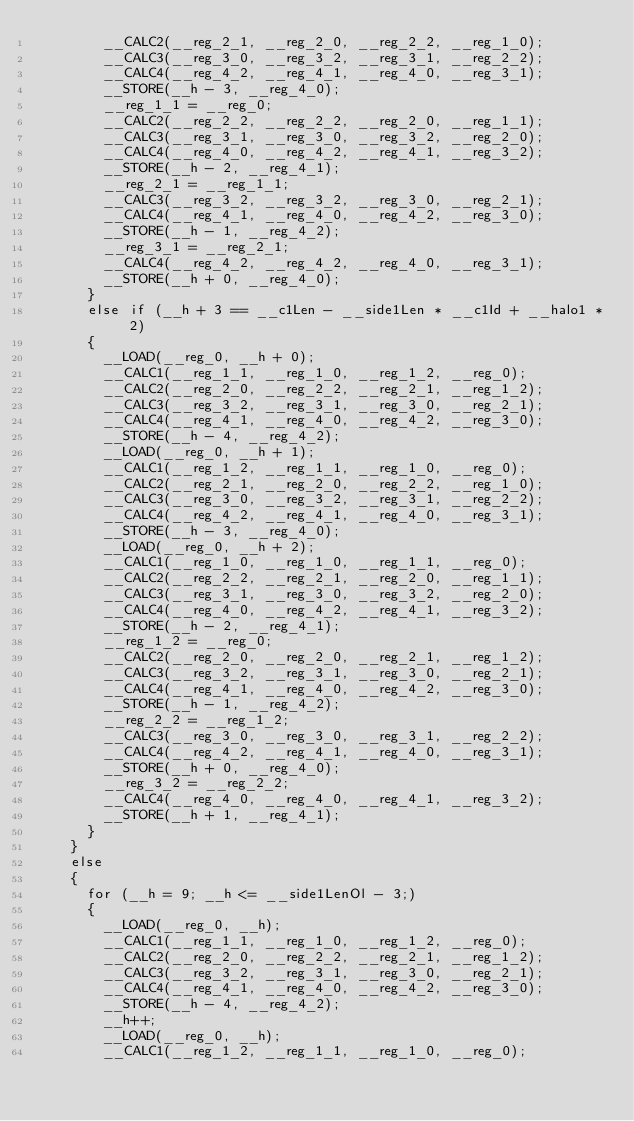<code> <loc_0><loc_0><loc_500><loc_500><_Cuda_>        __CALC2(__reg_2_1, __reg_2_0, __reg_2_2, __reg_1_0);
        __CALC3(__reg_3_0, __reg_3_2, __reg_3_1, __reg_2_2);
        __CALC4(__reg_4_2, __reg_4_1, __reg_4_0, __reg_3_1);
        __STORE(__h - 3, __reg_4_0);
        __reg_1_1 = __reg_0;
        __CALC2(__reg_2_2, __reg_2_2, __reg_2_0, __reg_1_1);
        __CALC3(__reg_3_1, __reg_3_0, __reg_3_2, __reg_2_0);
        __CALC4(__reg_4_0, __reg_4_2, __reg_4_1, __reg_3_2);
        __STORE(__h - 2, __reg_4_1);
        __reg_2_1 = __reg_1_1;
        __CALC3(__reg_3_2, __reg_3_2, __reg_3_0, __reg_2_1);
        __CALC4(__reg_4_1, __reg_4_0, __reg_4_2, __reg_3_0);
        __STORE(__h - 1, __reg_4_2);
        __reg_3_1 = __reg_2_1;
        __CALC4(__reg_4_2, __reg_4_2, __reg_4_0, __reg_3_1);
        __STORE(__h + 0, __reg_4_0);
      }
      else if (__h + 3 == __c1Len - __side1Len * __c1Id + __halo1 * 2)
      {
        __LOAD(__reg_0, __h + 0);
        __CALC1(__reg_1_1, __reg_1_0, __reg_1_2, __reg_0);
        __CALC2(__reg_2_0, __reg_2_2, __reg_2_1, __reg_1_2);
        __CALC3(__reg_3_2, __reg_3_1, __reg_3_0, __reg_2_1);
        __CALC4(__reg_4_1, __reg_4_0, __reg_4_2, __reg_3_0);
        __STORE(__h - 4, __reg_4_2);
        __LOAD(__reg_0, __h + 1);
        __CALC1(__reg_1_2, __reg_1_1, __reg_1_0, __reg_0);
        __CALC2(__reg_2_1, __reg_2_0, __reg_2_2, __reg_1_0);
        __CALC3(__reg_3_0, __reg_3_2, __reg_3_1, __reg_2_2);
        __CALC4(__reg_4_2, __reg_4_1, __reg_4_0, __reg_3_1);
        __STORE(__h - 3, __reg_4_0);
        __LOAD(__reg_0, __h + 2);
        __CALC1(__reg_1_0, __reg_1_0, __reg_1_1, __reg_0);
        __CALC2(__reg_2_2, __reg_2_1, __reg_2_0, __reg_1_1);
        __CALC3(__reg_3_1, __reg_3_0, __reg_3_2, __reg_2_0);
        __CALC4(__reg_4_0, __reg_4_2, __reg_4_1, __reg_3_2);
        __STORE(__h - 2, __reg_4_1);
        __reg_1_2 = __reg_0;
        __CALC2(__reg_2_0, __reg_2_0, __reg_2_1, __reg_1_2);
        __CALC3(__reg_3_2, __reg_3_1, __reg_3_0, __reg_2_1);
        __CALC4(__reg_4_1, __reg_4_0, __reg_4_2, __reg_3_0);
        __STORE(__h - 1, __reg_4_2);
        __reg_2_2 = __reg_1_2;
        __CALC3(__reg_3_0, __reg_3_0, __reg_3_1, __reg_2_2);
        __CALC4(__reg_4_2, __reg_4_1, __reg_4_0, __reg_3_1);
        __STORE(__h + 0, __reg_4_0);
        __reg_3_2 = __reg_2_2;
        __CALC4(__reg_4_0, __reg_4_0, __reg_4_1, __reg_3_2);
        __STORE(__h + 1, __reg_4_1);
      }
    }
    else
    {
      for (__h = 9; __h <= __side1LenOl - 3;)
      {
        __LOAD(__reg_0, __h);
        __CALC1(__reg_1_1, __reg_1_0, __reg_1_2, __reg_0);
        __CALC2(__reg_2_0, __reg_2_2, __reg_2_1, __reg_1_2);
        __CALC3(__reg_3_2, __reg_3_1, __reg_3_0, __reg_2_1);
        __CALC4(__reg_4_1, __reg_4_0, __reg_4_2, __reg_3_0);
        __STORE(__h - 4, __reg_4_2);
        __h++;
        __LOAD(__reg_0, __h);
        __CALC1(__reg_1_2, __reg_1_1, __reg_1_0, __reg_0);</code> 